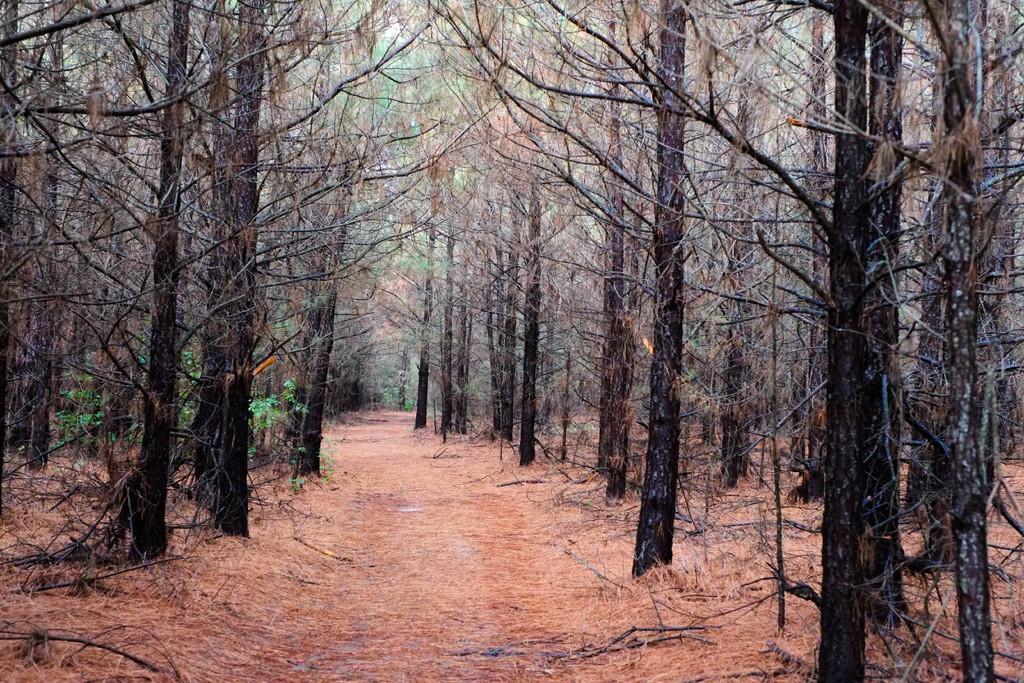Could you give a brief overview of what you see in this image? This place is looking like a forest. At the bottom there is a path and on the both sides there are many trees. 